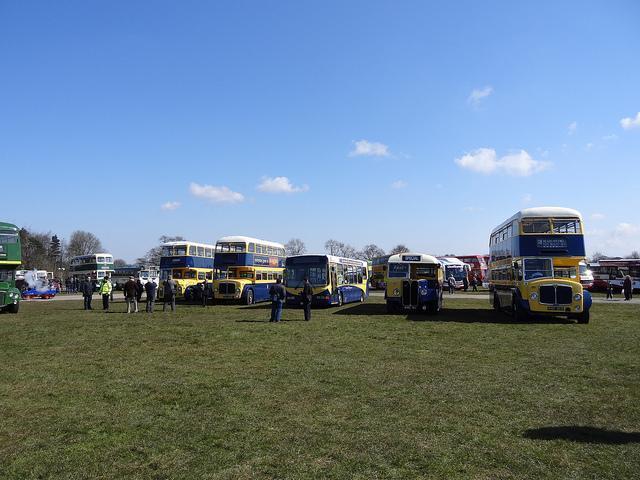How many buses can you see?
Give a very brief answer. 5. 